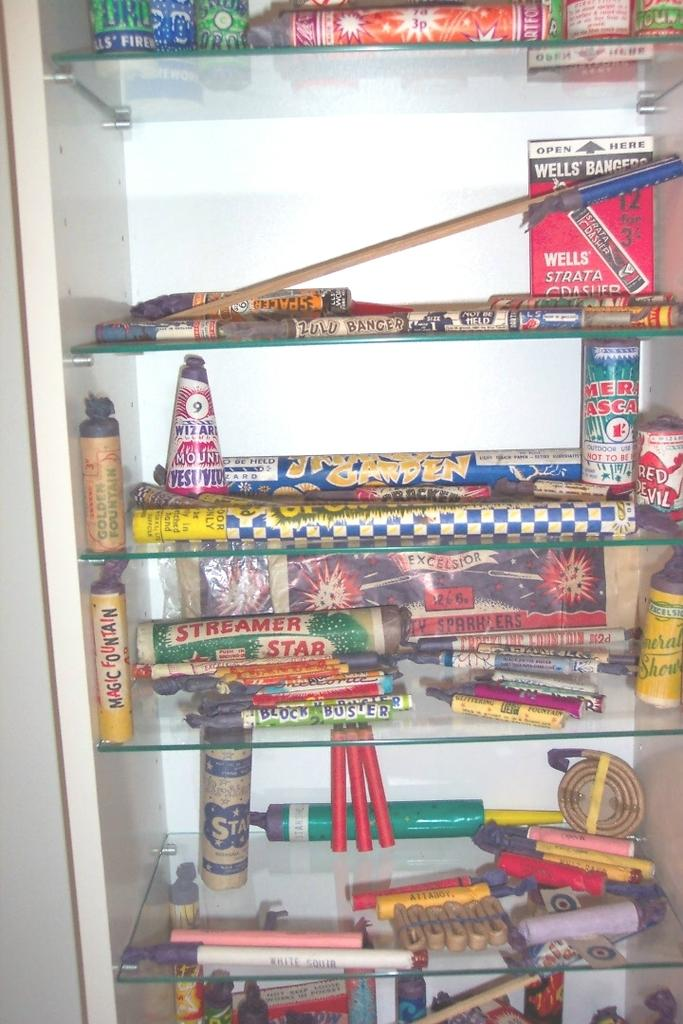What type of furniture is in the image? There is a cabinet in the image. How many shelves does the cabinet have? The cabinet has multiple shelves. What items can be seen on the shelves of the cabinet? Different types of crackers are present on the shelves of the cabinet. What type of flag is hanging from the cork on the cabinet in the image? There is no flag or cork present in the image; it only features a cabinet with shelves containing crackers. 